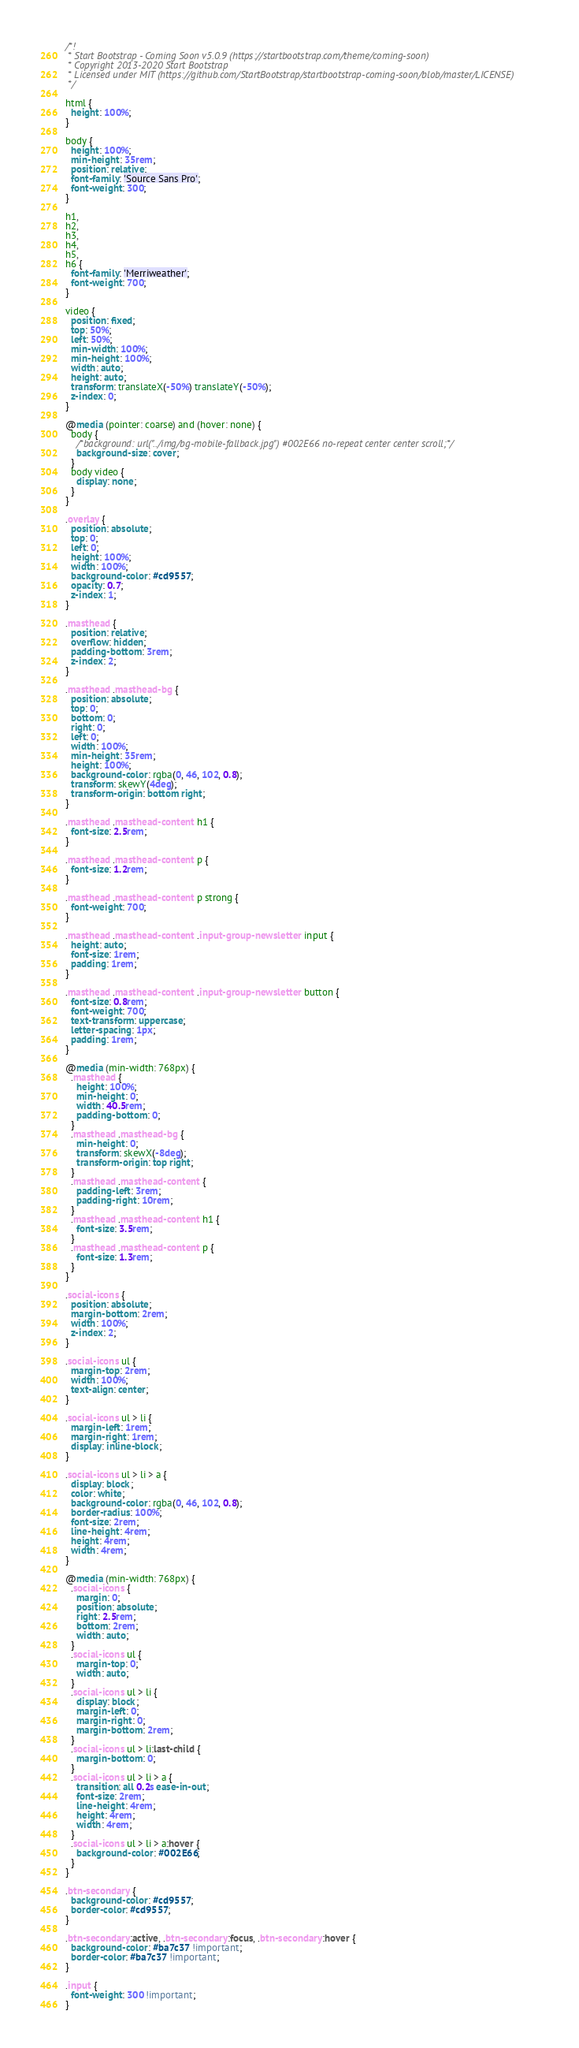<code> <loc_0><loc_0><loc_500><loc_500><_CSS_>/*!
 * Start Bootstrap - Coming Soon v5.0.9 (https://startbootstrap.com/theme/coming-soon)
 * Copyright 2013-2020 Start Bootstrap
 * Licensed under MIT (https://github.com/StartBootstrap/startbootstrap-coming-soon/blob/master/LICENSE)
 */

html {
  height: 100%;
}

body {
  height: 100%;
  min-height: 35rem;
  position: relative;
  font-family: 'Source Sans Pro';
  font-weight: 300;
}

h1,
h2,
h3,
h4,
h5,
h6 {
  font-family: 'Merriweather';
  font-weight: 700;
}

video {
  position: fixed;
  top: 50%;
  left: 50%;
  min-width: 100%;
  min-height: 100%;
  width: auto;
  height: auto;
  transform: translateX(-50%) translateY(-50%);
  z-index: 0;
}

@media (pointer: coarse) and (hover: none) {
  body {
    /*background: url("../img/bg-mobile-fallback.jpg") #002E66 no-repeat center center scroll;*/
    background-size: cover;
  }
  body video {
    display: none;
  }
}

.overlay {
  position: absolute;
  top: 0;
  left: 0;
  height: 100%;
  width: 100%;
  background-color: #cd9557;
  opacity: 0.7;
  z-index: 1;
}

.masthead {
  position: relative;
  overflow: hidden;
  padding-bottom: 3rem;
  z-index: 2;
}

.masthead .masthead-bg {
  position: absolute;
  top: 0;
  bottom: 0;
  right: 0;
  left: 0;
  width: 100%;
  min-height: 35rem;
  height: 100%;
  background-color: rgba(0, 46, 102, 0.8);
  transform: skewY(4deg);
  transform-origin: bottom right;
}

.masthead .masthead-content h1 {
  font-size: 2.5rem;
}

.masthead .masthead-content p {
  font-size: 1.2rem;
}

.masthead .masthead-content p strong {
  font-weight: 700;
}

.masthead .masthead-content .input-group-newsletter input {
  height: auto;
  font-size: 1rem;
  padding: 1rem;
}

.masthead .masthead-content .input-group-newsletter button {
  font-size: 0.8rem;
  font-weight: 700;
  text-transform: uppercase;
  letter-spacing: 1px;
  padding: 1rem;
}

@media (min-width: 768px) {
  .masthead {
    height: 100%;
    min-height: 0;
    width: 40.5rem;
    padding-bottom: 0;
  }
  .masthead .masthead-bg {
    min-height: 0;
    transform: skewX(-8deg);
    transform-origin: top right;
  }
  .masthead .masthead-content {
    padding-left: 3rem;
    padding-right: 10rem;
  }
  .masthead .masthead-content h1 {
    font-size: 3.5rem;
  }
  .masthead .masthead-content p {
    font-size: 1.3rem;
  }
}

.social-icons {
  position: absolute;
  margin-bottom: 2rem;
  width: 100%;
  z-index: 2;
}

.social-icons ul {
  margin-top: 2rem;
  width: 100%;
  text-align: center;
}

.social-icons ul > li {
  margin-left: 1rem;
  margin-right: 1rem;
  display: inline-block;
}

.social-icons ul > li > a {
  display: block;
  color: white;
  background-color: rgba(0, 46, 102, 0.8);
  border-radius: 100%;
  font-size: 2rem;
  line-height: 4rem;
  height: 4rem;
  width: 4rem;
}

@media (min-width: 768px) {
  .social-icons {
    margin: 0;
    position: absolute;
    right: 2.5rem;
    bottom: 2rem;
    width: auto;
  }
  .social-icons ul {
    margin-top: 0;
    width: auto;
  }
  .social-icons ul > li {
    display: block;
    margin-left: 0;
    margin-right: 0;
    margin-bottom: 2rem;
  }
  .social-icons ul > li:last-child {
    margin-bottom: 0;
  }
  .social-icons ul > li > a {
    transition: all 0.2s ease-in-out;
    font-size: 2rem;
    line-height: 4rem;
    height: 4rem;
    width: 4rem;
  }
  .social-icons ul > li > a:hover {
    background-color: #002E66;
  }
}

.btn-secondary {
  background-color: #cd9557;
  border-color: #cd9557;
}

.btn-secondary:active, .btn-secondary:focus, .btn-secondary:hover {
  background-color: #ba7c37 !important;
  border-color: #ba7c37 !important;
}

.input {
  font-weight: 300 !important;
}
</code> 